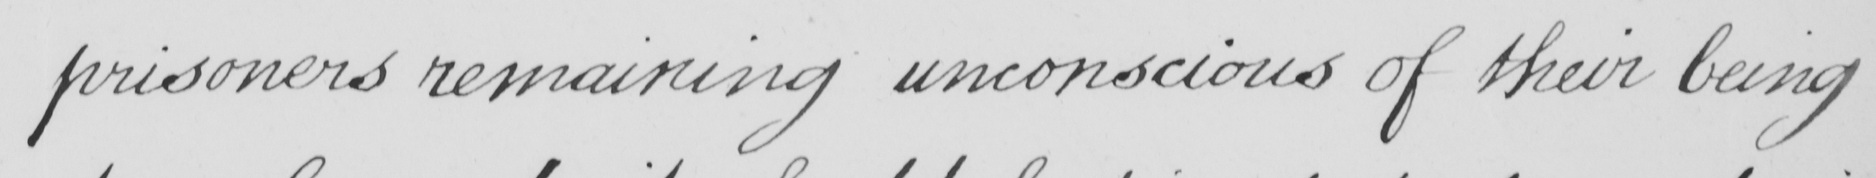What does this handwritten line say? prisoners remaining unconscious of their being 